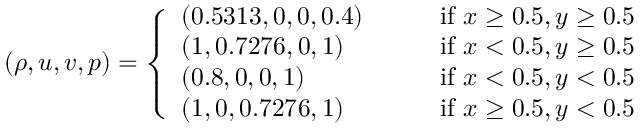<formula> <loc_0><loc_0><loc_500><loc_500>\begin{array} { r } { ( \rho , u , v , p ) = \left \{ \begin{array} { l l } { ( 0 . 5 3 1 3 , 0 , 0 , 0 . 4 ) \quad } & { i f x \geq 0 . 5 , y \geq 0 . 5 } \\ { ( 1 , 0 . 7 2 7 6 , 0 , 1 ) } & { i f x < 0 . 5 , y \geq 0 . 5 } \\ { ( 0 . 8 , 0 , 0 , 1 ) } & { i f x < 0 . 5 , y < 0 . 5 } \\ { ( 1 , 0 , 0 . 7 2 7 6 , 1 ) } & { i f x \geq 0 . 5 , y < 0 . 5 } \end{array} } \end{array}</formula> 